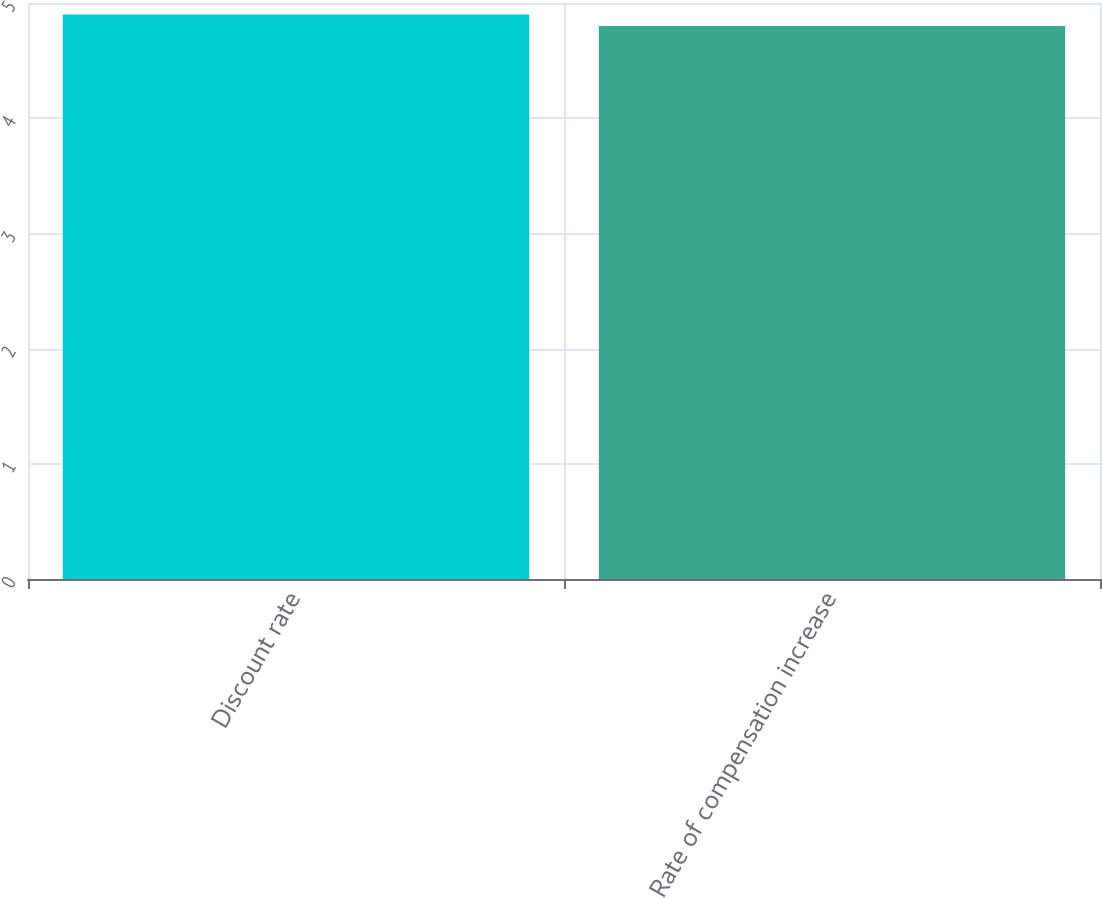Convert chart to OTSL. <chart><loc_0><loc_0><loc_500><loc_500><bar_chart><fcel>Discount rate<fcel>Rate of compensation increase<nl><fcel>4.9<fcel>4.8<nl></chart> 